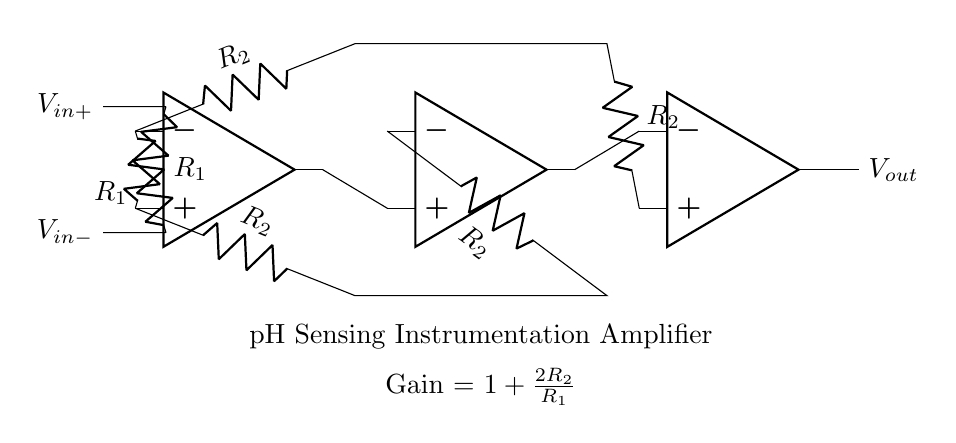What is the type of amplifier depicted in the circuit? The circuit is an instrumentation amplifier. This can be identified by the arrangement of multiple operational amplifiers designed for high gain and precision.
Answer: instrumentation amplifier How many operational amplifiers are used in the circuit? The circuit uses three operational amplifiers. This is clear from the symbols drawn in the diagram, indicating each amplifier's location.
Answer: three What is the purpose of the resistors labeled R1? The resistors labeled R1 are used for setting the input impedance and determining the gain of the amplifier. They connect the input terminals to the operational amplifiers.
Answer: input impedance What effect does increasing the value of R2 have on the amplifier's gain? Increasing the value of R2 will increase the gain of the amplifier. The gain formula shows that gain is directly proportional to R2, thus higher resistance leads to a higher output voltage.
Answer: increase gain What is the gain formula for this instrumentation amplifier? The gain formula is expressed as one plus twice the resistance of R2 divided by R1. This can be observed below the amplifier in the circuit diagram, outlining how gain is calculated in relation to the resistors.
Answer: one plus two R2 over R1 What are the input voltage terminals of the amplifier labeled as? The input voltage terminals are labeled as V in plus and V in minus. This is indicated by the labels attached to the input connections in the diagram.
Answer: V in plus and V in minus What is the significance of the output voltage in this circuit? The output voltage indicates the amplified signal corresponding to the sensed pH changes in the drug formulation. It connects to the output terminal of the last operational amplifier in the configuration.
Answer: amplified signal 